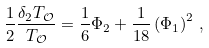Convert formula to latex. <formula><loc_0><loc_0><loc_500><loc_500>\frac { 1 } { 2 } \frac { \delta _ { 2 } T _ { \mathcal { O } } } { T _ { \mathcal { O } } } = \frac { 1 } { 6 } \Phi _ { 2 } + \frac { 1 } { 1 8 } \left ( \Phi _ { 1 } \right ) ^ { 2 } \, ,</formula> 